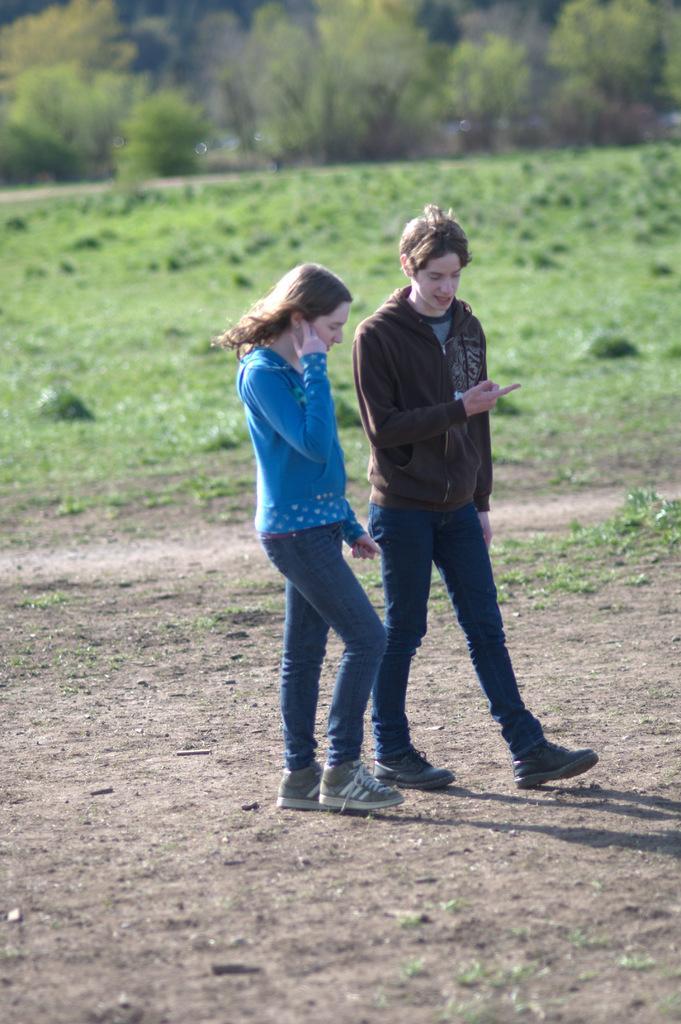Describe this image in one or two sentences. In the center of the image a lady and a man are walking on a ground. In the background of the image grass is present. At the top of the image trees are there. 